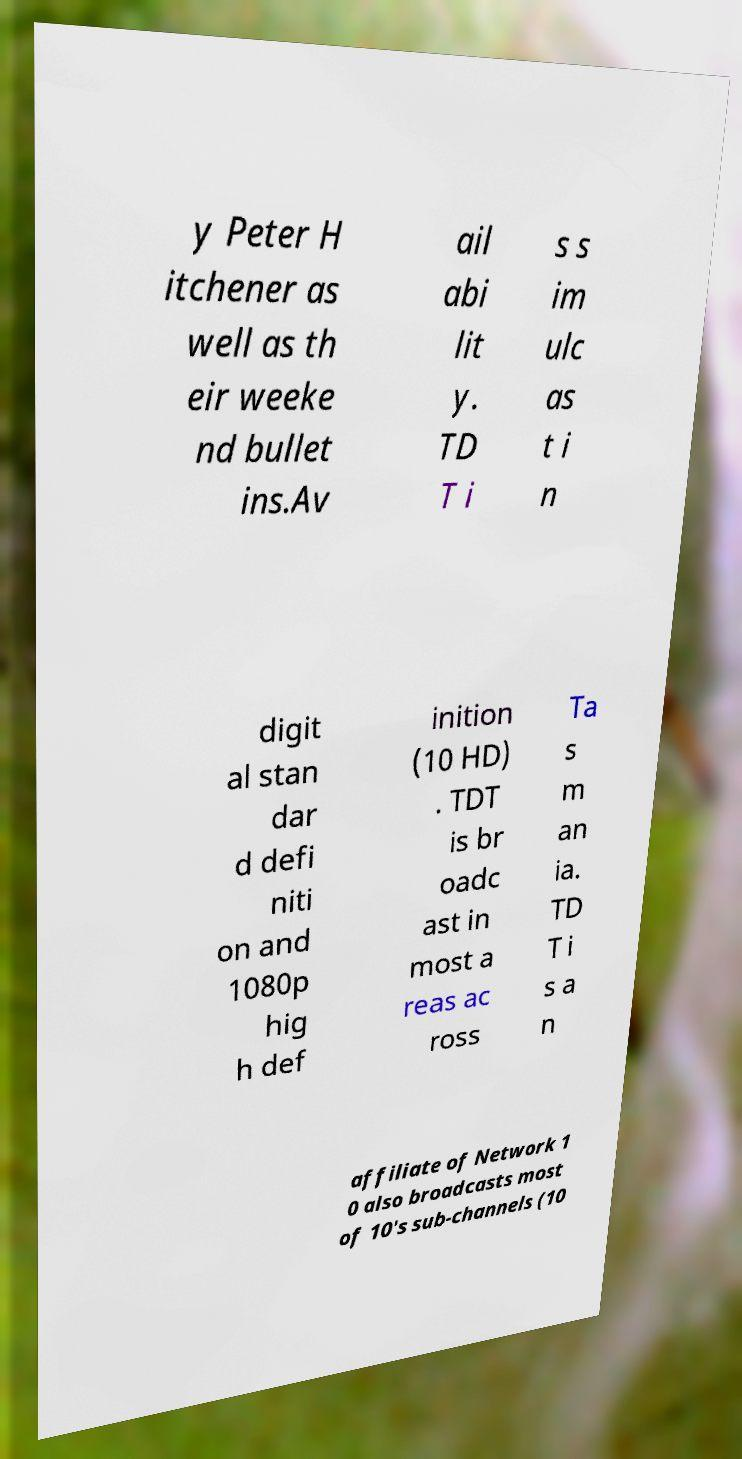Can you read and provide the text displayed in the image?This photo seems to have some interesting text. Can you extract and type it out for me? y Peter H itchener as well as th eir weeke nd bullet ins.Av ail abi lit y. TD T i s s im ulc as t i n digit al stan dar d defi niti on and 1080p hig h def inition (10 HD) . TDT is br oadc ast in most a reas ac ross Ta s m an ia. TD T i s a n affiliate of Network 1 0 also broadcasts most of 10's sub-channels (10 